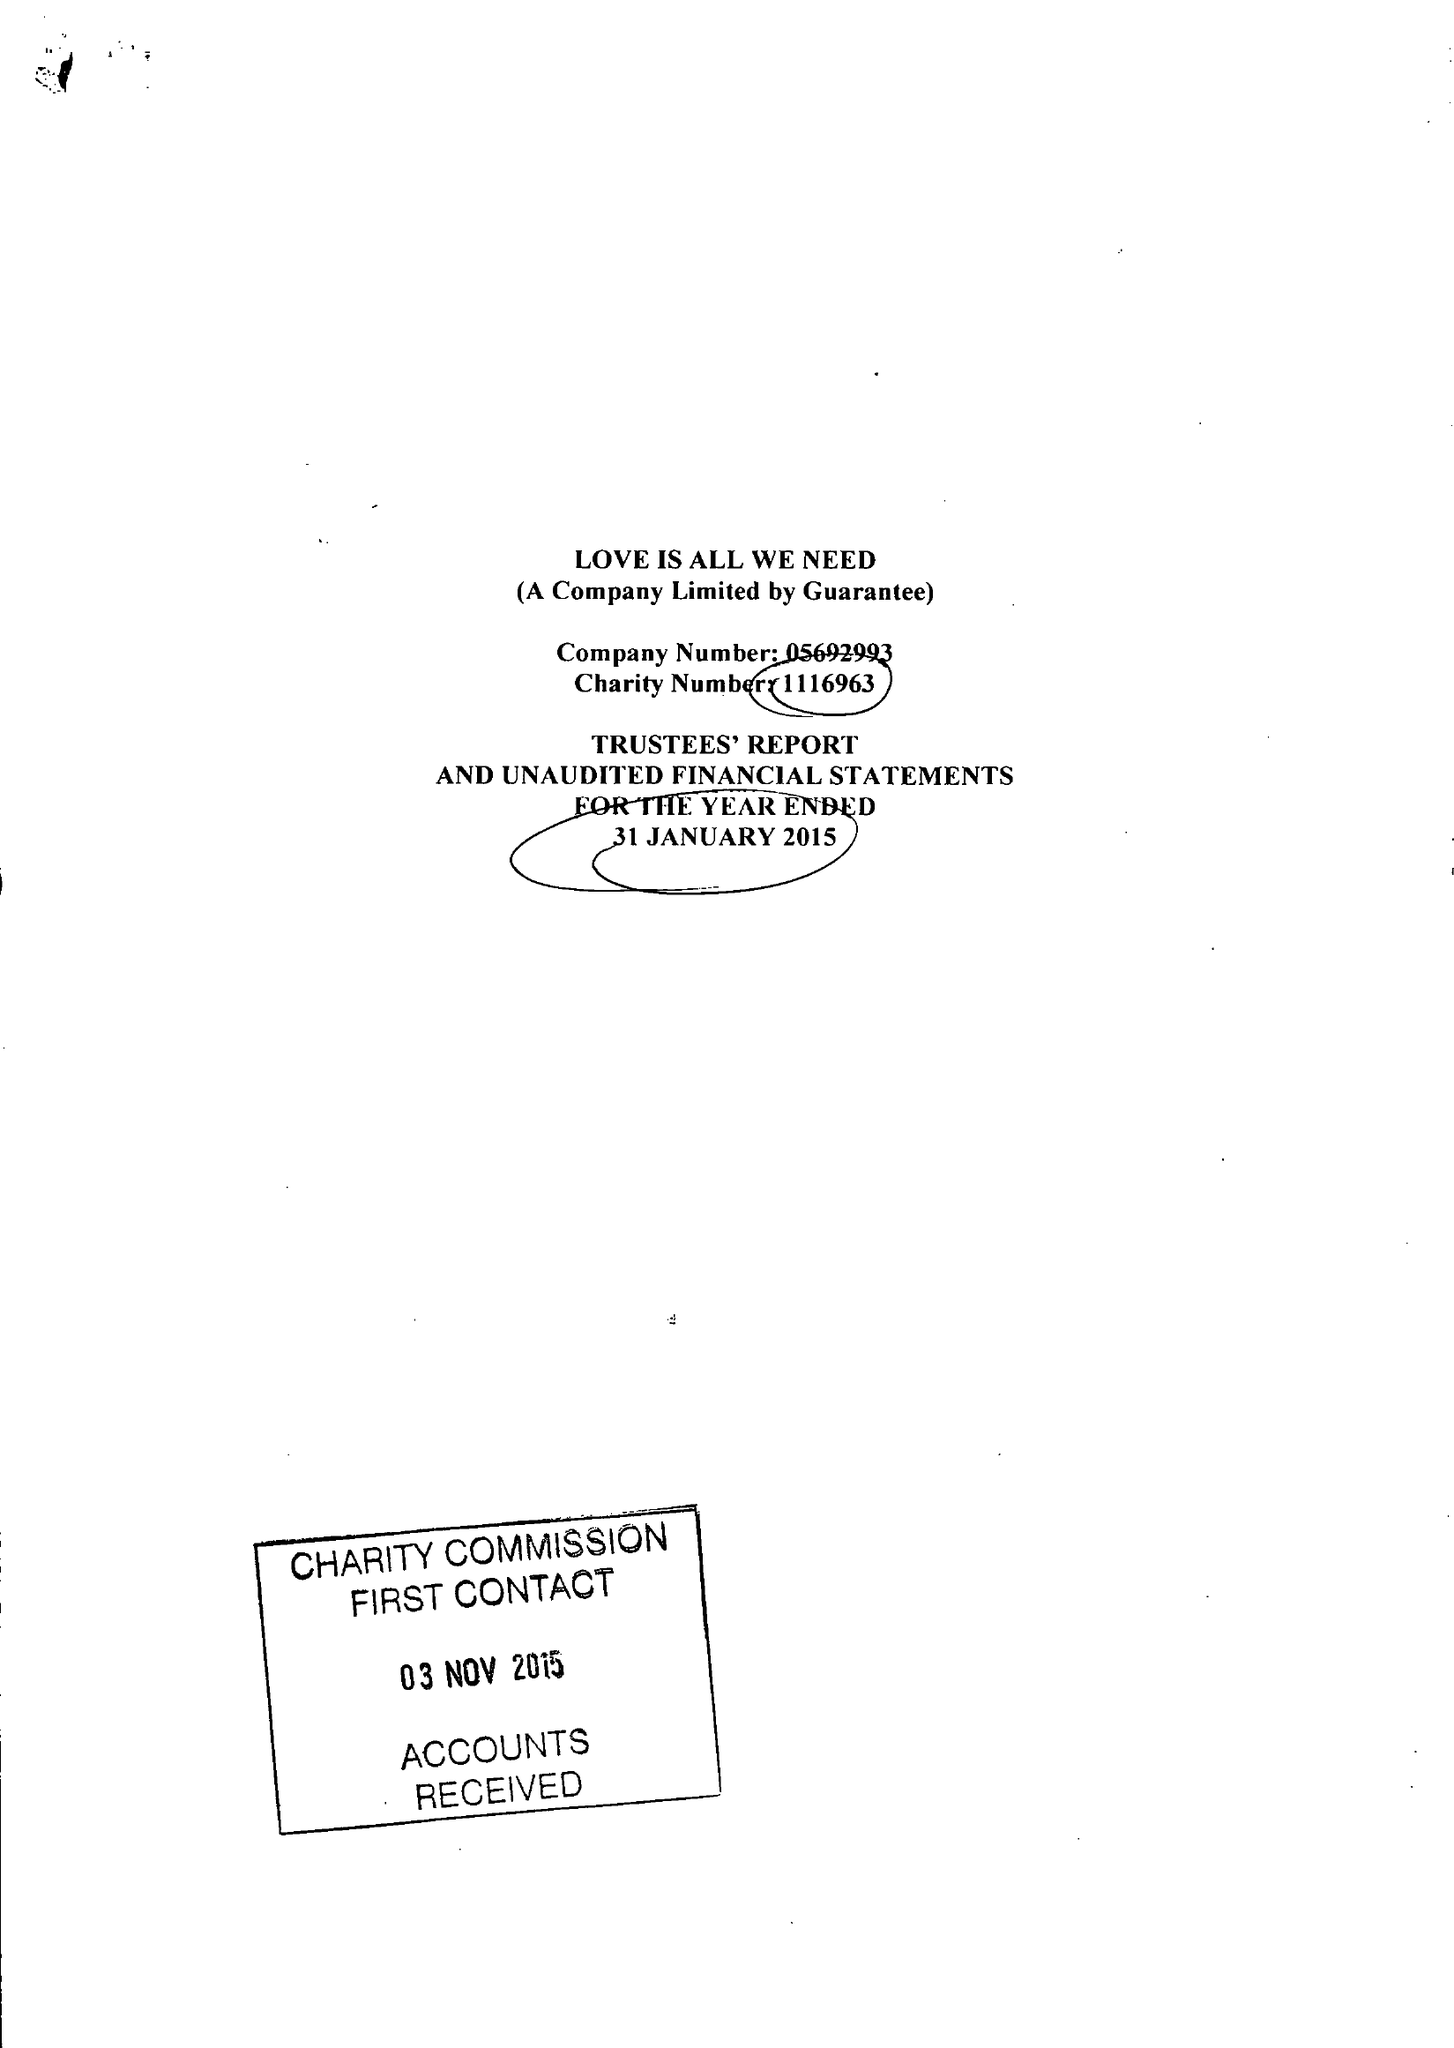What is the value for the address__post_town?
Answer the question using a single word or phrase. HOVE 